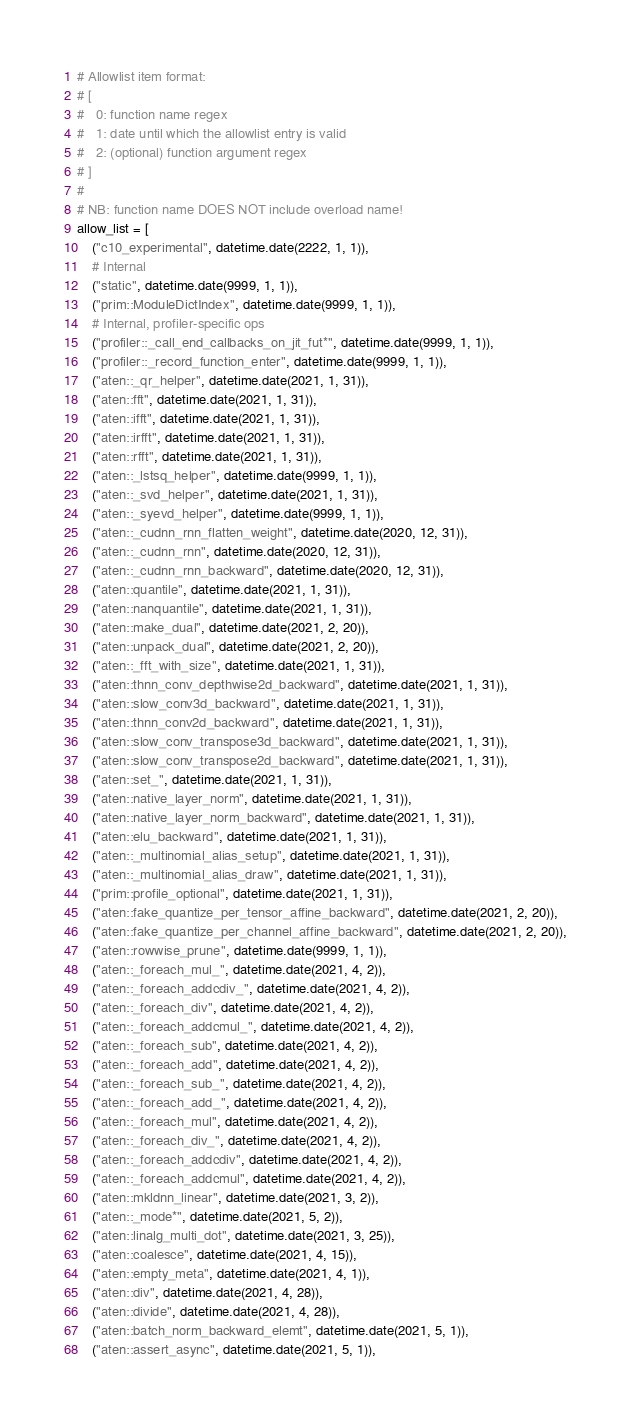Convert code to text. <code><loc_0><loc_0><loc_500><loc_500><_Python_># Allowlist item format:
# [
#   0: function name regex
#   1: date until which the allowlist entry is valid
#   2: (optional) function argument regex
# ]
#
# NB: function name DOES NOT include overload name!
allow_list = [
    ("c10_experimental", datetime.date(2222, 1, 1)),
    # Internal
    ("static", datetime.date(9999, 1, 1)),
    ("prim::ModuleDictIndex", datetime.date(9999, 1, 1)),
    # Internal, profiler-specific ops
    ("profiler::_call_end_callbacks_on_jit_fut*", datetime.date(9999, 1, 1)),
    ("profiler::_record_function_enter", datetime.date(9999, 1, 1)),
    ("aten::_qr_helper", datetime.date(2021, 1, 31)),
    ("aten::fft", datetime.date(2021, 1, 31)),
    ("aten::ifft", datetime.date(2021, 1, 31)),
    ("aten::irfft", datetime.date(2021, 1, 31)),
    ("aten::rfft", datetime.date(2021, 1, 31)),
    ("aten::_lstsq_helper", datetime.date(9999, 1, 1)),
    ("aten::_svd_helper", datetime.date(2021, 1, 31)),
    ("aten::_syevd_helper", datetime.date(9999, 1, 1)),
    ("aten::_cudnn_rnn_flatten_weight", datetime.date(2020, 12, 31)),
    ("aten::_cudnn_rnn", datetime.date(2020, 12, 31)),
    ("aten::_cudnn_rnn_backward", datetime.date(2020, 12, 31)),
    ("aten::quantile", datetime.date(2021, 1, 31)),
    ("aten::nanquantile", datetime.date(2021, 1, 31)),
    ("aten::make_dual", datetime.date(2021, 2, 20)),
    ("aten::unpack_dual", datetime.date(2021, 2, 20)),
    ("aten::_fft_with_size", datetime.date(2021, 1, 31)),
    ("aten::thnn_conv_depthwise2d_backward", datetime.date(2021, 1, 31)),
    ("aten::slow_conv3d_backward", datetime.date(2021, 1, 31)),
    ("aten::thnn_conv2d_backward", datetime.date(2021, 1, 31)),
    ("aten::slow_conv_transpose3d_backward", datetime.date(2021, 1, 31)),
    ("aten::slow_conv_transpose2d_backward", datetime.date(2021, 1, 31)),
    ("aten::set_", datetime.date(2021, 1, 31)),
    ("aten::native_layer_norm", datetime.date(2021, 1, 31)),
    ("aten::native_layer_norm_backward", datetime.date(2021, 1, 31)),
    ("aten::elu_backward", datetime.date(2021, 1, 31)),
    ("aten::_multinomial_alias_setup", datetime.date(2021, 1, 31)),
    ("aten::_multinomial_alias_draw", datetime.date(2021, 1, 31)),
    ("prim::profile_optional", datetime.date(2021, 1, 31)),
    ("aten::fake_quantize_per_tensor_affine_backward", datetime.date(2021, 2, 20)),
    ("aten::fake_quantize_per_channel_affine_backward", datetime.date(2021, 2, 20)),
    ("aten::rowwise_prune", datetime.date(9999, 1, 1)),
    ("aten::_foreach_mul_", datetime.date(2021, 4, 2)),
    ("aten::_foreach_addcdiv_", datetime.date(2021, 4, 2)),
    ("aten::_foreach_div", datetime.date(2021, 4, 2)),
    ("aten::_foreach_addcmul_", datetime.date(2021, 4, 2)),
    ("aten::_foreach_sub", datetime.date(2021, 4, 2)),
    ("aten::_foreach_add", datetime.date(2021, 4, 2)),
    ("aten::_foreach_sub_", datetime.date(2021, 4, 2)),
    ("aten::_foreach_add_", datetime.date(2021, 4, 2)),
    ("aten::_foreach_mul", datetime.date(2021, 4, 2)),
    ("aten::_foreach_div_", datetime.date(2021, 4, 2)),
    ("aten::_foreach_addcdiv", datetime.date(2021, 4, 2)),
    ("aten::_foreach_addcmul", datetime.date(2021, 4, 2)),
    ("aten::mkldnn_linear", datetime.date(2021, 3, 2)),
    ("aten::_mode*", datetime.date(2021, 5, 2)),
    ("aten::linalg_multi_dot", datetime.date(2021, 3, 25)),
    ("aten::coalesce", datetime.date(2021, 4, 15)),
    ("aten::empty_meta", datetime.date(2021, 4, 1)),
    ("aten::div", datetime.date(2021, 4, 28)),
    ("aten::divide", datetime.date(2021, 4, 28)),
    ("aten::batch_norm_backward_elemt", datetime.date(2021, 5, 1)),
    ("aten::assert_async", datetime.date(2021, 5, 1)),</code> 